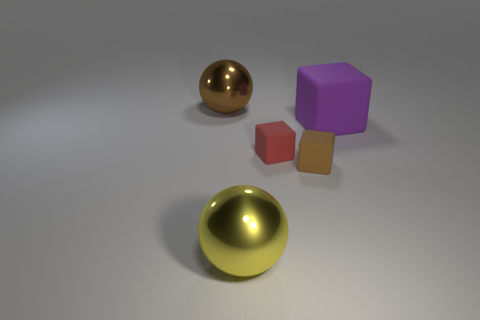Add 2 blocks. How many objects exist? 7 Subtract all tiny blocks. How many blocks are left? 1 Subtract all yellow spheres. How many spheres are left? 1 Subtract 2 spheres. How many spheres are left? 0 Subtract all spheres. How many objects are left? 3 Subtract all gray balls. Subtract all gray blocks. How many balls are left? 2 Subtract all brown balls. How many red cubes are left? 1 Subtract all gray metal cylinders. Subtract all large shiny objects. How many objects are left? 3 Add 3 large yellow shiny things. How many large yellow shiny things are left? 4 Add 4 big gray balls. How many big gray balls exist? 4 